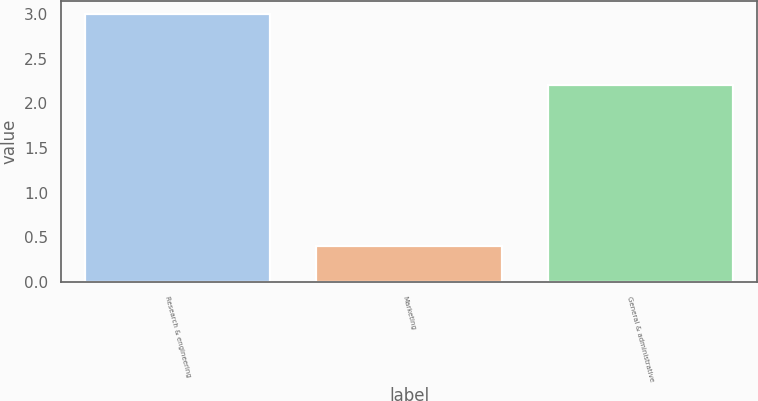Convert chart. <chart><loc_0><loc_0><loc_500><loc_500><bar_chart><fcel>Research & engineering<fcel>Marketing<fcel>General & administrative<nl><fcel>3<fcel>0.4<fcel>2.2<nl></chart> 